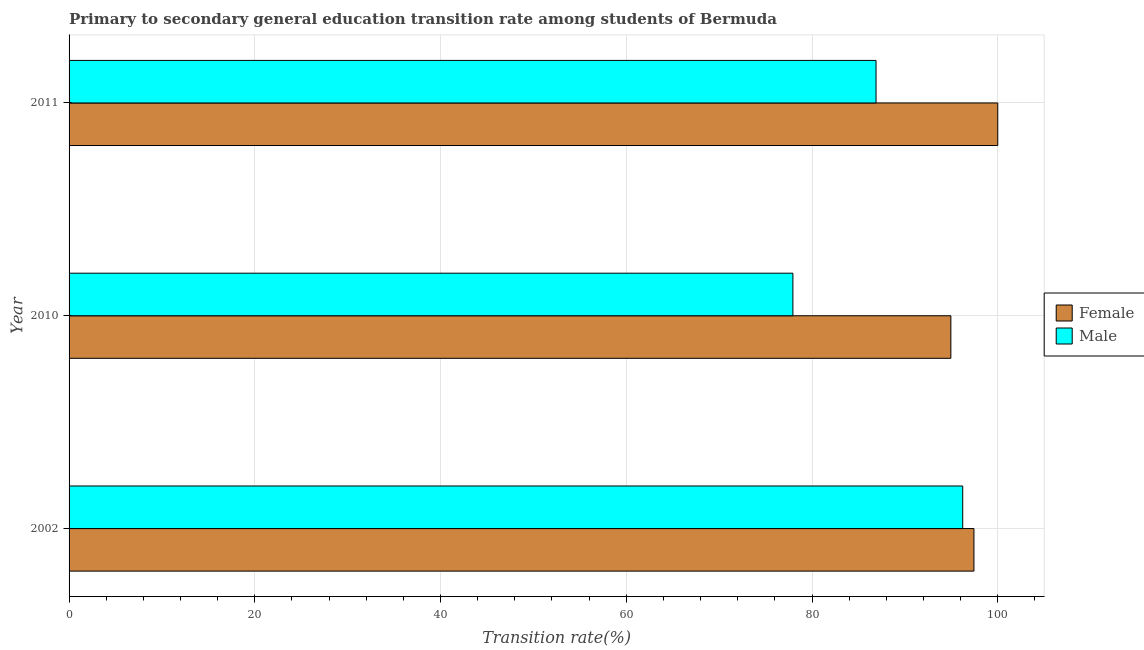How many groups of bars are there?
Offer a very short reply. 3. Are the number of bars on each tick of the Y-axis equal?
Your response must be concise. Yes. How many bars are there on the 2nd tick from the top?
Ensure brevity in your answer.  2. How many bars are there on the 2nd tick from the bottom?
Make the answer very short. 2. What is the label of the 1st group of bars from the top?
Your response must be concise. 2011. What is the transition rate among male students in 2002?
Keep it short and to the point. 96.23. Across all years, what is the maximum transition rate among male students?
Make the answer very short. 96.23. Across all years, what is the minimum transition rate among female students?
Make the answer very short. 94.95. In which year was the transition rate among male students minimum?
Your answer should be compact. 2010. What is the total transition rate among female students in the graph?
Give a very brief answer. 292.39. What is the difference between the transition rate among male students in 2002 and that in 2010?
Your answer should be compact. 18.29. What is the difference between the transition rate among female students in 2010 and the transition rate among male students in 2011?
Give a very brief answer. 8.06. What is the average transition rate among male students per year?
Your answer should be very brief. 87.02. In the year 2011, what is the difference between the transition rate among female students and transition rate among male students?
Your response must be concise. 13.11. What is the ratio of the transition rate among male students in 2002 to that in 2010?
Your answer should be compact. 1.24. Is the difference between the transition rate among male students in 2002 and 2010 greater than the difference between the transition rate among female students in 2002 and 2010?
Offer a very short reply. Yes. What is the difference between the highest and the second highest transition rate among male students?
Your answer should be very brief. 9.33. What is the difference between the highest and the lowest transition rate among male students?
Offer a very short reply. 18.29. In how many years, is the transition rate among female students greater than the average transition rate among female students taken over all years?
Your answer should be compact. 1. Are all the bars in the graph horizontal?
Make the answer very short. Yes. How many years are there in the graph?
Your answer should be compact. 3. Does the graph contain grids?
Keep it short and to the point. Yes. How many legend labels are there?
Provide a short and direct response. 2. What is the title of the graph?
Keep it short and to the point. Primary to secondary general education transition rate among students of Bermuda. Does "Resident workers" appear as one of the legend labels in the graph?
Provide a short and direct response. No. What is the label or title of the X-axis?
Your answer should be compact. Transition rate(%). What is the label or title of the Y-axis?
Offer a very short reply. Year. What is the Transition rate(%) in Female in 2002?
Keep it short and to the point. 97.44. What is the Transition rate(%) in Male in 2002?
Give a very brief answer. 96.23. What is the Transition rate(%) in Female in 2010?
Your response must be concise. 94.95. What is the Transition rate(%) of Male in 2010?
Provide a short and direct response. 77.94. What is the Transition rate(%) of Male in 2011?
Make the answer very short. 86.89. Across all years, what is the maximum Transition rate(%) in Female?
Offer a terse response. 100. Across all years, what is the maximum Transition rate(%) in Male?
Offer a very short reply. 96.23. Across all years, what is the minimum Transition rate(%) of Female?
Provide a succinct answer. 94.95. Across all years, what is the minimum Transition rate(%) of Male?
Offer a very short reply. 77.94. What is the total Transition rate(%) in Female in the graph?
Make the answer very short. 292.39. What is the total Transition rate(%) in Male in the graph?
Your response must be concise. 261.06. What is the difference between the Transition rate(%) in Female in 2002 and that in 2010?
Your answer should be very brief. 2.49. What is the difference between the Transition rate(%) of Male in 2002 and that in 2010?
Give a very brief answer. 18.29. What is the difference between the Transition rate(%) of Female in 2002 and that in 2011?
Provide a short and direct response. -2.56. What is the difference between the Transition rate(%) in Male in 2002 and that in 2011?
Ensure brevity in your answer.  9.33. What is the difference between the Transition rate(%) of Female in 2010 and that in 2011?
Offer a very short reply. -5.05. What is the difference between the Transition rate(%) in Male in 2010 and that in 2011?
Give a very brief answer. -8.95. What is the difference between the Transition rate(%) in Female in 2002 and the Transition rate(%) in Male in 2010?
Offer a very short reply. 19.49. What is the difference between the Transition rate(%) in Female in 2002 and the Transition rate(%) in Male in 2011?
Offer a very short reply. 10.54. What is the difference between the Transition rate(%) of Female in 2010 and the Transition rate(%) of Male in 2011?
Your answer should be compact. 8.06. What is the average Transition rate(%) in Female per year?
Your response must be concise. 97.46. What is the average Transition rate(%) in Male per year?
Ensure brevity in your answer.  87.02. In the year 2002, what is the difference between the Transition rate(%) in Female and Transition rate(%) in Male?
Your answer should be compact. 1.21. In the year 2010, what is the difference between the Transition rate(%) in Female and Transition rate(%) in Male?
Offer a terse response. 17.01. In the year 2011, what is the difference between the Transition rate(%) of Female and Transition rate(%) of Male?
Provide a succinct answer. 13.11. What is the ratio of the Transition rate(%) in Female in 2002 to that in 2010?
Provide a succinct answer. 1.03. What is the ratio of the Transition rate(%) in Male in 2002 to that in 2010?
Provide a short and direct response. 1.23. What is the ratio of the Transition rate(%) of Female in 2002 to that in 2011?
Provide a succinct answer. 0.97. What is the ratio of the Transition rate(%) in Male in 2002 to that in 2011?
Keep it short and to the point. 1.11. What is the ratio of the Transition rate(%) in Female in 2010 to that in 2011?
Offer a terse response. 0.95. What is the ratio of the Transition rate(%) in Male in 2010 to that in 2011?
Provide a succinct answer. 0.9. What is the difference between the highest and the second highest Transition rate(%) in Female?
Your answer should be compact. 2.56. What is the difference between the highest and the second highest Transition rate(%) in Male?
Make the answer very short. 9.33. What is the difference between the highest and the lowest Transition rate(%) of Female?
Offer a very short reply. 5.05. What is the difference between the highest and the lowest Transition rate(%) of Male?
Your answer should be very brief. 18.29. 